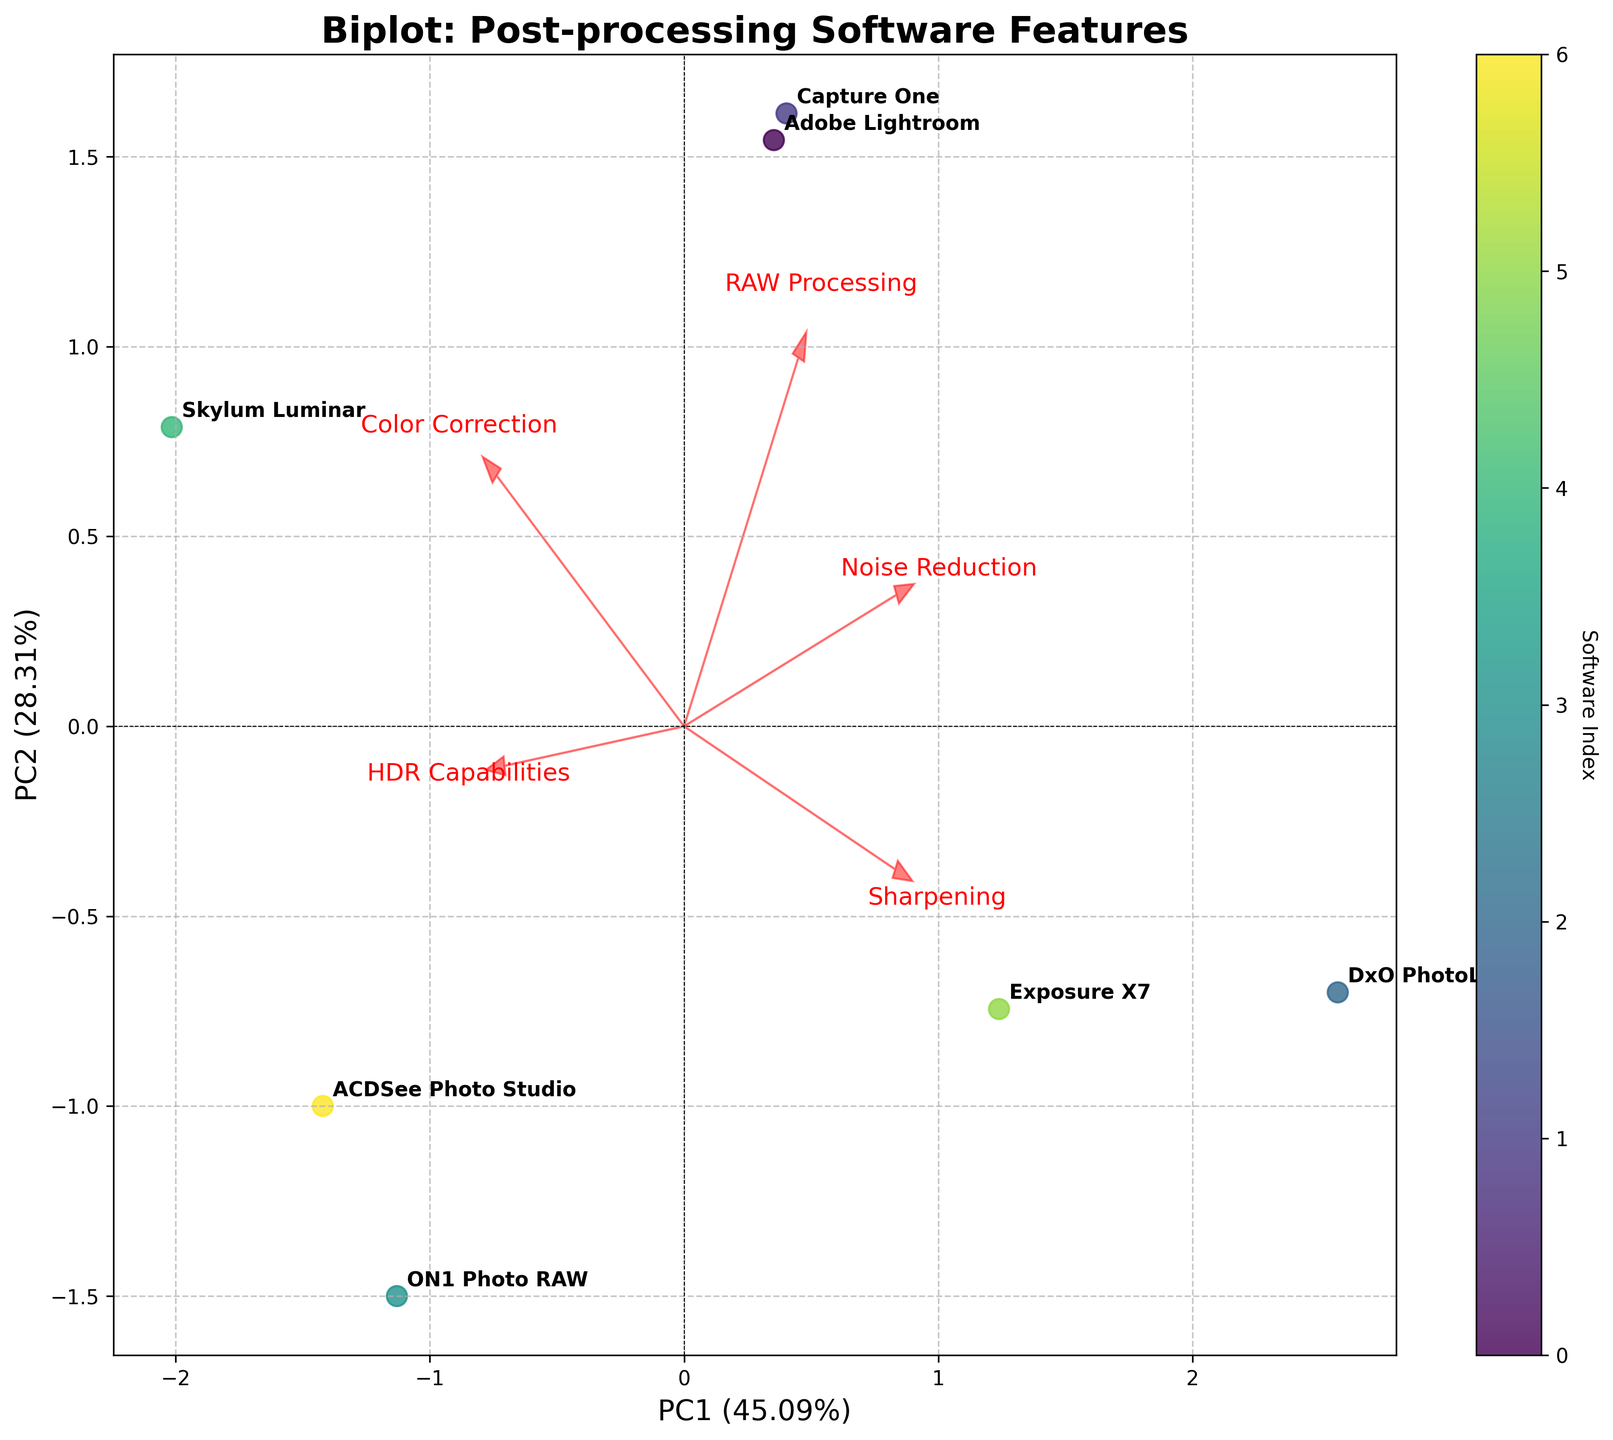What is the title of the figure? The title of the figure can be found at the top and it says "Biplot: Post-processing Software Features." This shows that the figure is about comparing different post-processing software based on their features using a biplot visualization.
Answer: Biplot: Post-processing Software Features How many software products are represented in the figure? Count the number of unique annotations representing the different software products in the plot. The figure has annotations for Adobe Lightroom, Capture One, DxO PhotoLab, ON1 Photo RAW, Skylum Luminar, Exposure X7, and ACDSee Photo Studio.
Answer: 7 Which software has the highest value for noise reduction? Look for the longest arrow pointing towards the Noise Reduction feature and find the software closest to this direction. The longest arrow for Noise Reduction mostly aligns with DxO PhotoLab, indicating it has the highest value for this feature.
Answer: DxO PhotoLab What percentage of the total variance is explained by PC1 and PC2 together? The figure labels the axes with their respective explained variance percentages. Add the two percentages together from the axis labels. If PC1 explains 60% and PC2 explains 30%, the total explanation is 60% + 30% = 90%.
Answer: 90% Which feature has a high positive influence on PC2 but not much on PC1? Look at the arrows pointing towards the feature labels. Identify the arrow that points more vertically, indicating a high influence on PC2 but remains closer to the horizontal centerline, showing less influence on PC1. HDR Capabilities appears to have a high influence on PC2 with very little on PC1.
Answer: HDR Capabilities Which two software are closest to each other in the biplot? Find the two points (each representing a software) that are nearest to each other on the plot in terms of Euclidean distance. The closest pair of points seem to be Capture One and Skylum Luminar.
Answer: Capture One and Skylum Luminar Which feature is most positively correlated with PC1? Observe the direction of the arrows representing features. The arrow that extends farthest horizontally to the right identifies the feature most correlated with PC1. Color Correction is the feature most positively correlated with PC1.
Answer: Color Correction Are the positions of ACDSee Photo Studio and ON1 Photo RAW more similar or different with respect to PC1 and PC2? Look at the biplot positions relative to the axes. If both points have notably different positions either horizontally (PC1) or vertically (PC2), they're different. ACDSee Photo Studio and ON1 Photo RAW are situated differently in both horizontal and vertical dimensions on the plot.
Answer: different How are the features 'RAW Processing' and 'Color Correction' related in this biplot? Examine the angle between the arrows representing 'RAW Processing' and 'Color Correction'. A small angle implies a strong positive correlation. Both arrows are relatively close to each other, indicating a strong positive correlation.
Answer: positively correlated 